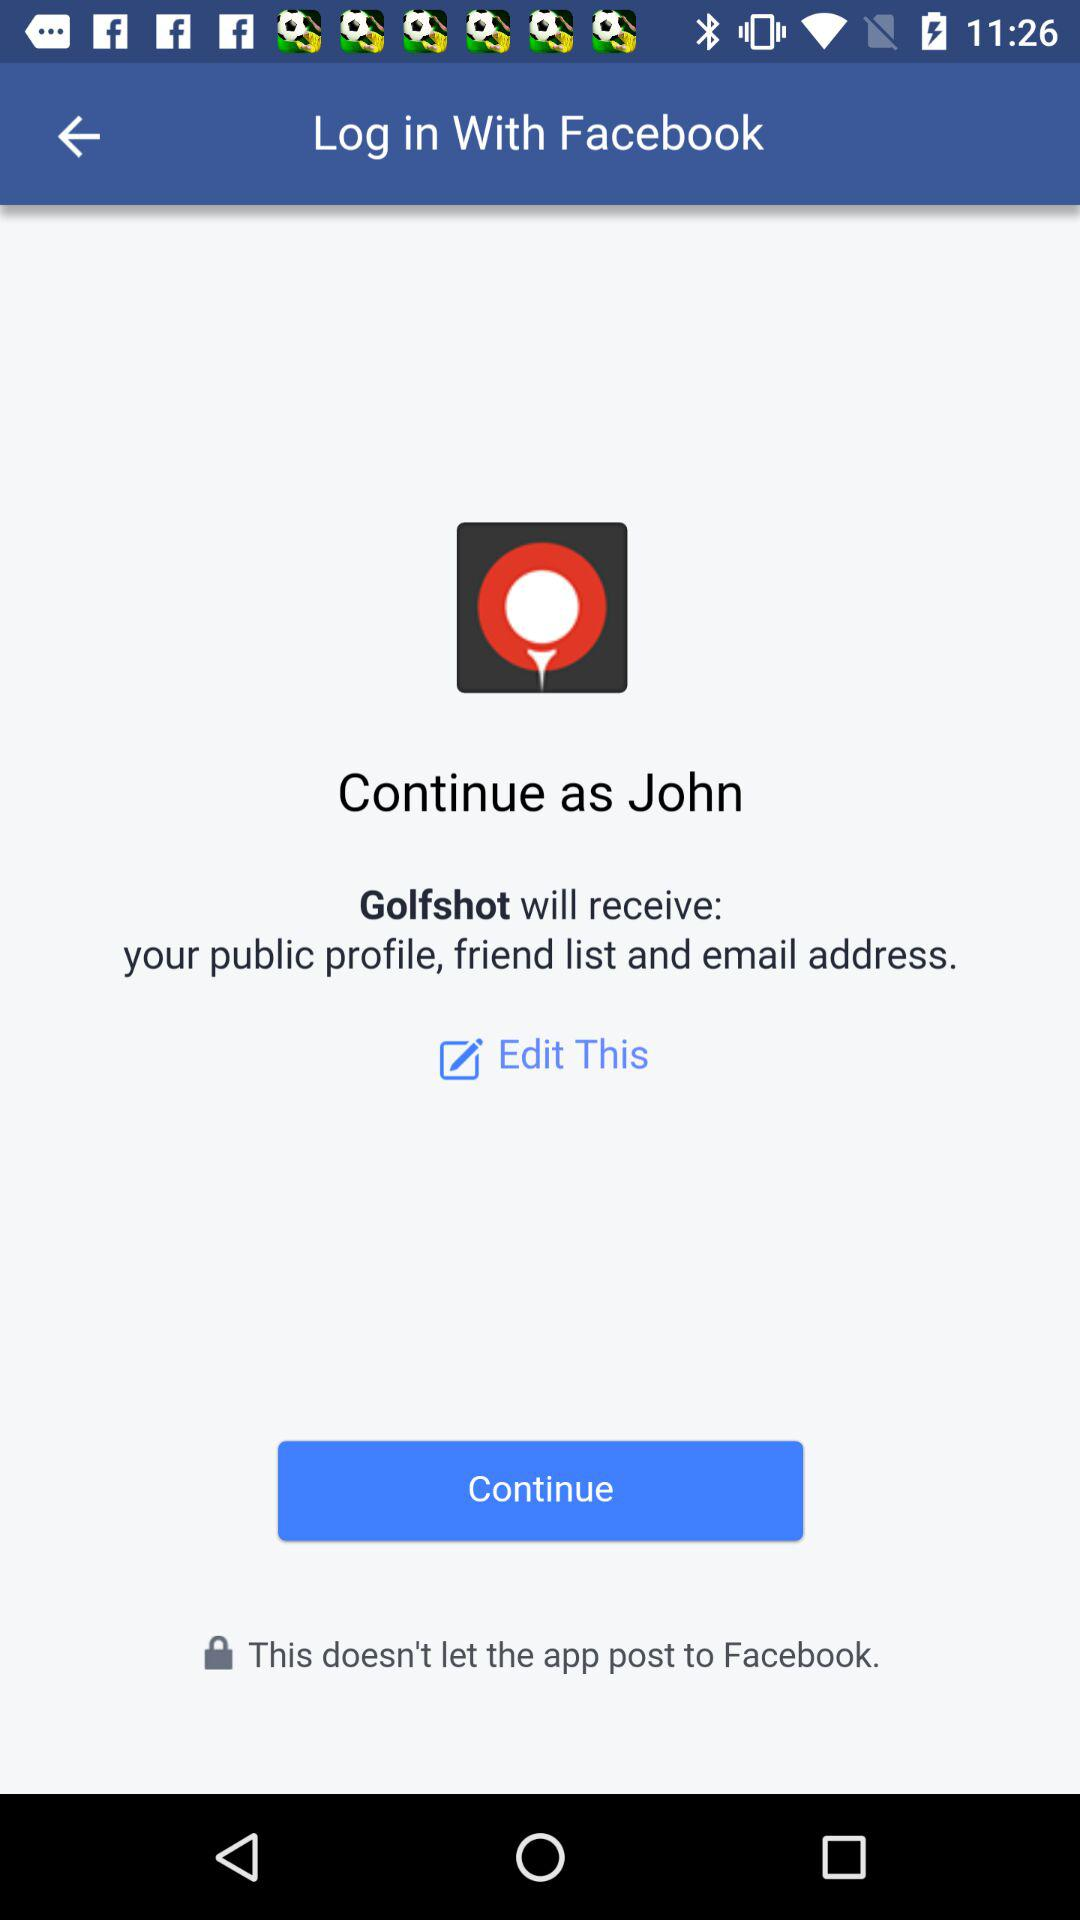What is the user name? The user name is John. 